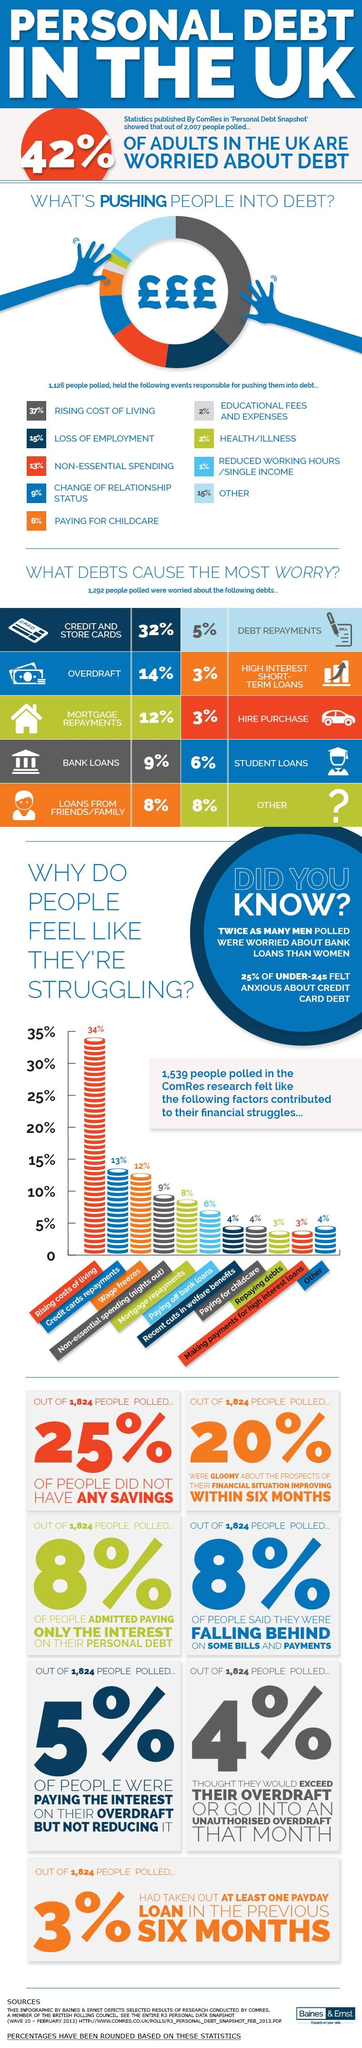Point out several critical features in this image. In the UK, approximately 58% of adults are not worried about debt. The top three reasons for debt are due to the rising cost of living, loss of employment, and non-essential spending. The most common reason that people struggle to pay debts is due to the rising costs of living. Out of 1,824 people polled, 456 people did not have any savings. According to the poll of 1,824 people, 80% were not gloomy about the prospects of improving their financial situation. 